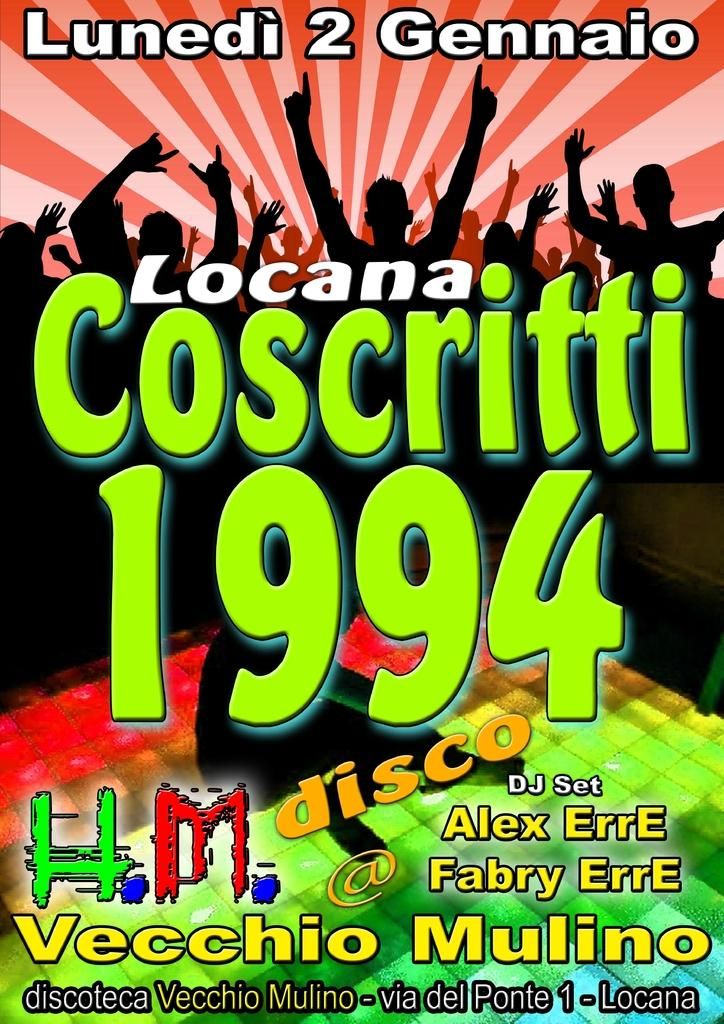<image>
Share a concise interpretation of the image provided. A poster for the Locana Coscritti 1994 disco 